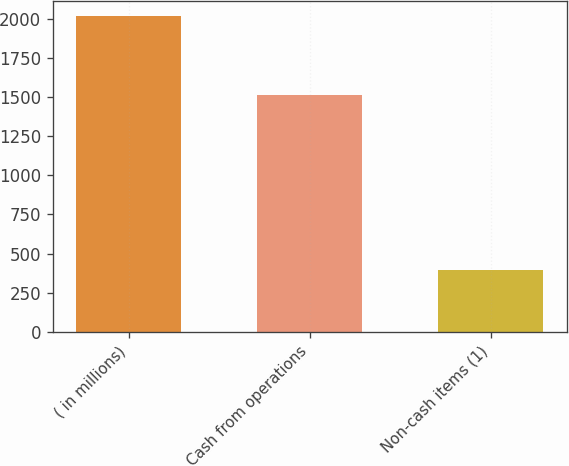<chart> <loc_0><loc_0><loc_500><loc_500><bar_chart><fcel>( in millions)<fcel>Cash from operations<fcel>Non-cash items (1)<nl><fcel>2015<fcel>1515<fcel>395<nl></chart> 